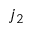Convert formula to latex. <formula><loc_0><loc_0><loc_500><loc_500>j _ { 2 }</formula> 